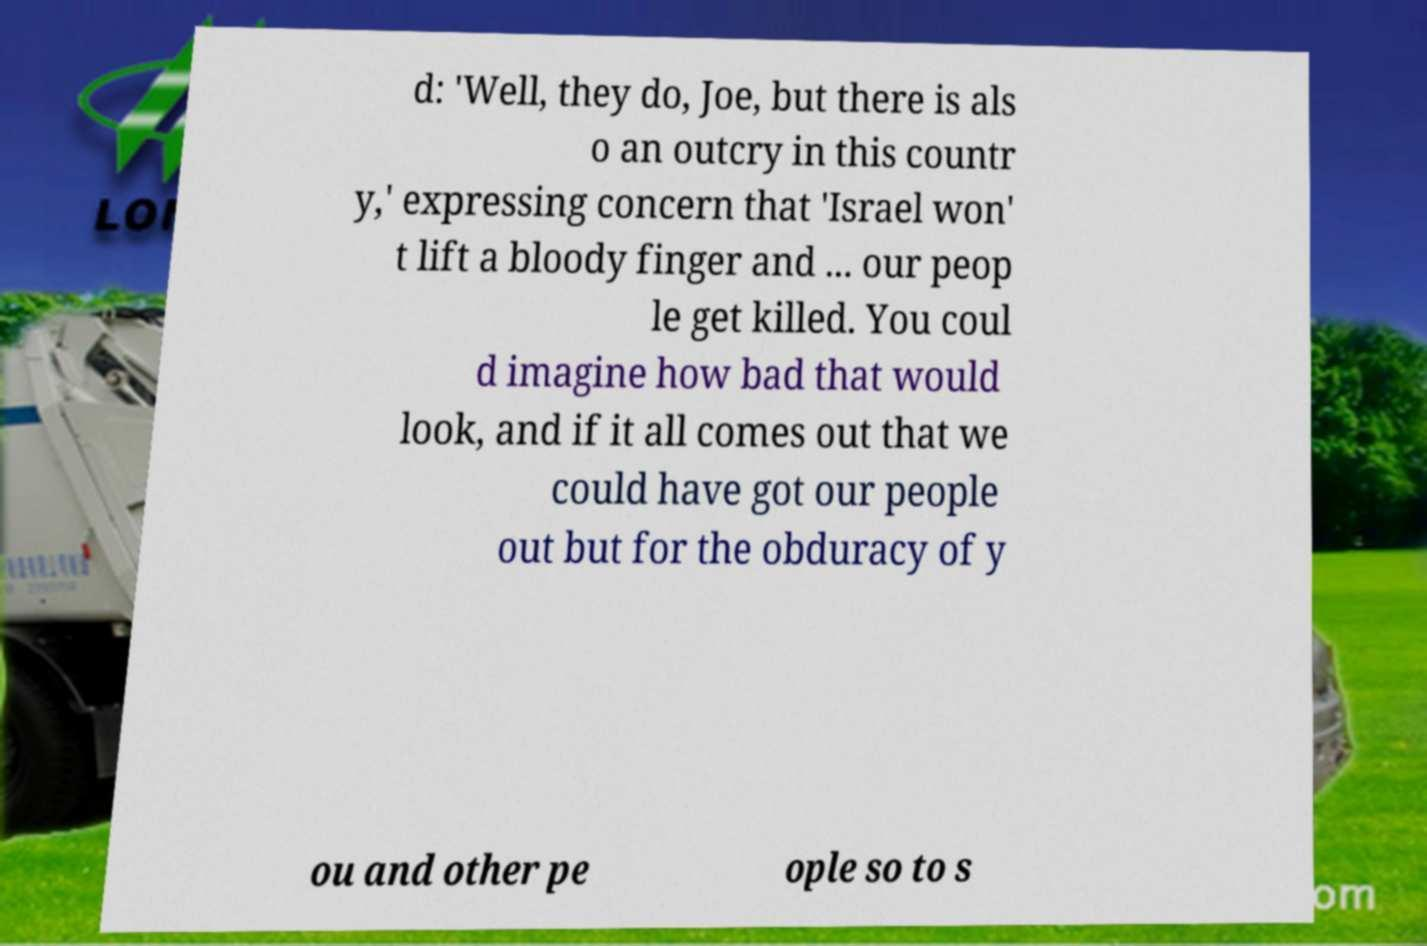Could you assist in decoding the text presented in this image and type it out clearly? d: 'Well, they do, Joe, but there is als o an outcry in this countr y,' expressing concern that 'Israel won' t lift a bloody finger and ... our peop le get killed. You coul d imagine how bad that would look, and if it all comes out that we could have got our people out but for the obduracy of y ou and other pe ople so to s 